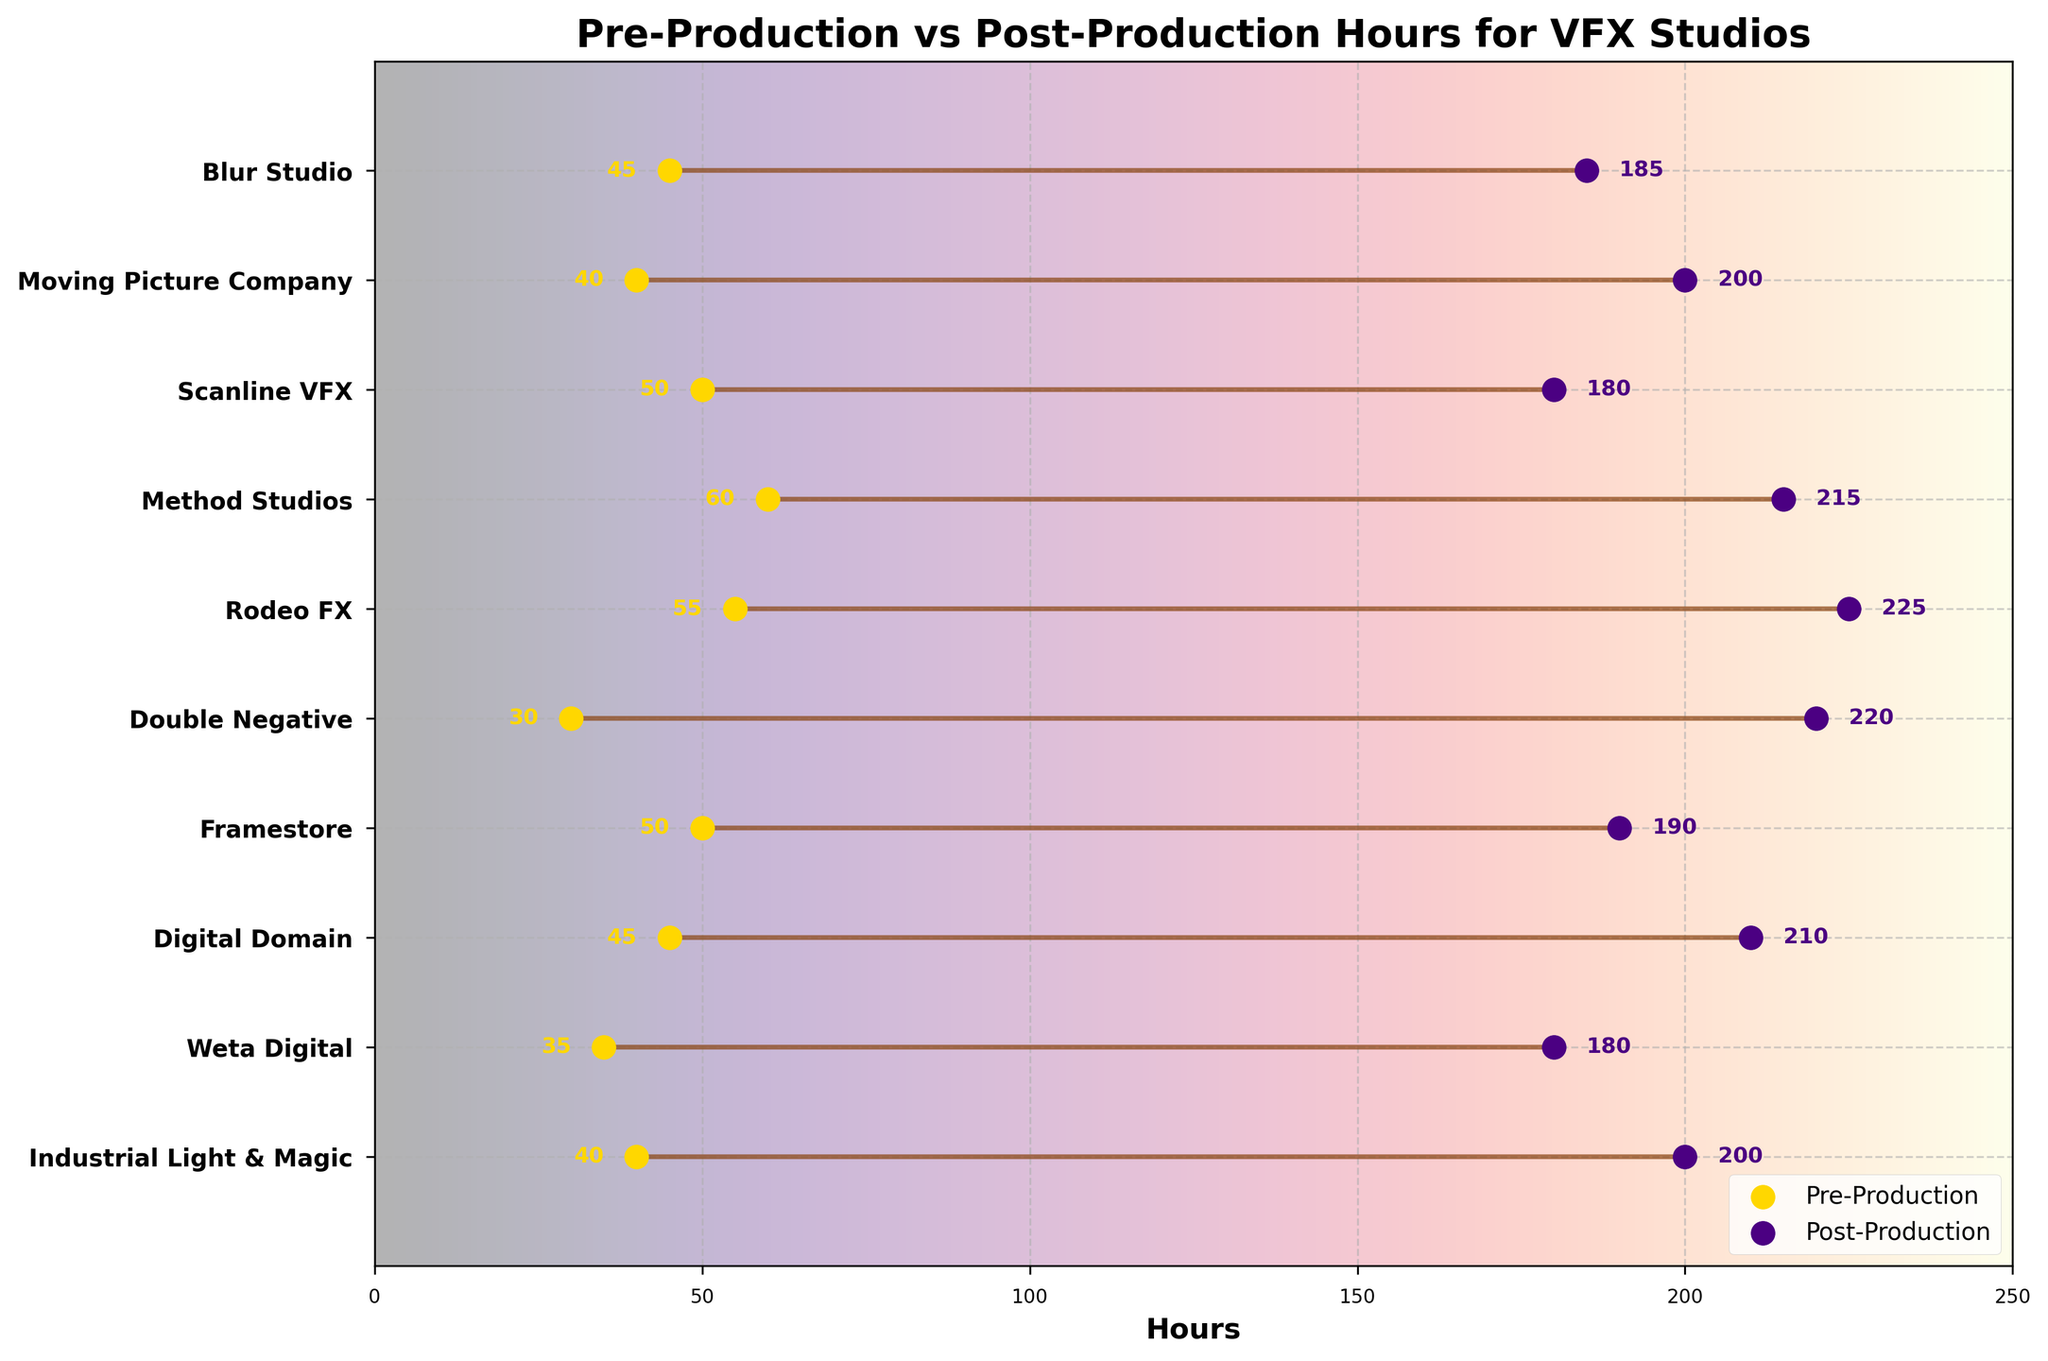what is the title of the plot? The title of the plot is found at the top of the figure, reading "Pre-Production vs Post-Production Hours for VFX Studios".
Answer: Pre-Production vs Post-Production Hours for VFX Studios How many studios are displayed in the plot? Count the total number of y-ticks (each corresponding to a studio) shown on the y-axis to determine the number of studios.
Answer: 10 Which studio had the highest number of post-production hours? Examine the post-production hours for each studio and identify the maximum value. Double Negative had 220 hours.
Answer: Double Negative What is the difference in pre-production hours between Method Studios and Rodeo FX? Subtract the number of pre-production hours of Rodeo FX (55) from Method Studios (60). 60 - 55 = 5.
Answer: 5 Which studio had the smallest gap between pre-production and post-production hours? Calculate the difference between pre-production and post-production hours for each studio. Framestore has the smallest gap: Post-Production (190) - Pre-Production (50) = 140.
Answer: Framestore What are the colors representing pre-production and post-production points? The pre-production points are indicated by a gold color, while the post-production points are represented by an indigo color.
Answer: gold and indigo How many hours did Moving Picture Company spend on post-production? Check the post-production hours for Moving Picture Company from the plot and find the value, which is 200.
Answer: 200 Which studio spent the most hours on pre-production? Identify the studio with the highest value in the pre-production category. Method Studios spent the most time with 60 hours.
Answer: Method Studios What’s the total number of hours spent on pre-production by Industrial Light & Magic, Weta Digital, and Digital Domain? Add the pre-production hours for the three studios: 40 (Industrial Light & Magic) + 35 (Weta Digital) + 45 (Digital Domain). 40 + 35 + 45 = 120.
Answer: 120 What is the average post-production time across all studios? Sum all the post-production hours and divide by the number of studios. Total = 200+180+210+190+220+225+215+180+200+185 = 2005. Average = 2005/10 = 200.5.
Answer: 200.5 